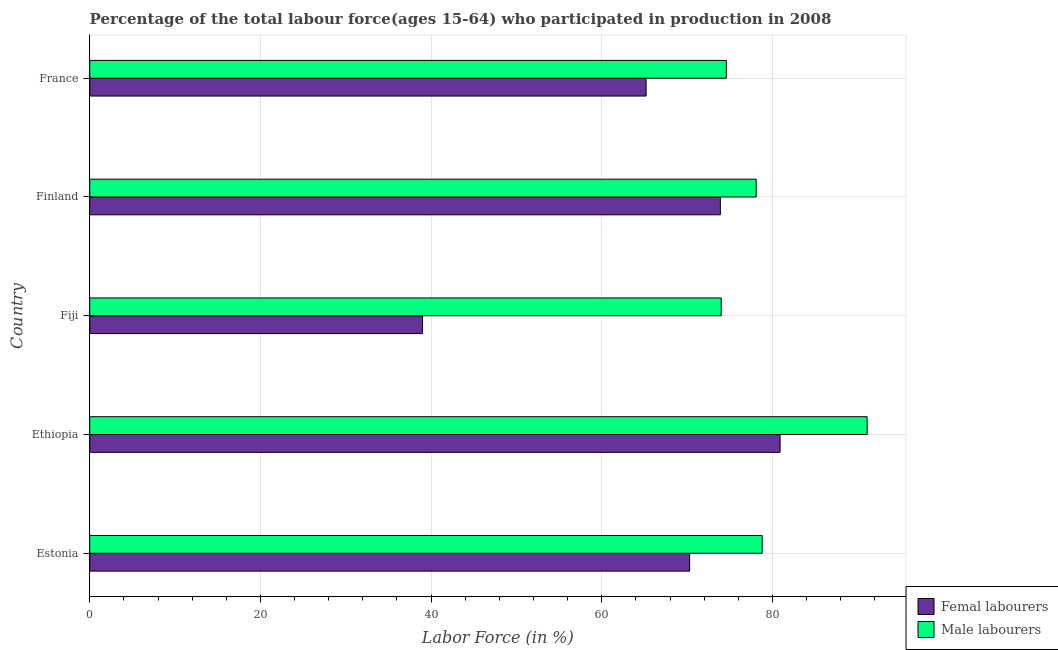How many groups of bars are there?
Your response must be concise. 5. Are the number of bars per tick equal to the number of legend labels?
Ensure brevity in your answer.  Yes. How many bars are there on the 5th tick from the bottom?
Offer a terse response. 2. What is the label of the 5th group of bars from the top?
Provide a short and direct response. Estonia. What is the percentage of male labour force in Estonia?
Provide a short and direct response. 78.8. Across all countries, what is the maximum percentage of female labor force?
Ensure brevity in your answer.  80.9. In which country was the percentage of female labor force maximum?
Your response must be concise. Ethiopia. In which country was the percentage of female labor force minimum?
Offer a very short reply. Fiji. What is the total percentage of female labor force in the graph?
Provide a succinct answer. 329.3. What is the difference between the percentage of female labor force in Estonia and the percentage of male labour force in Ethiopia?
Make the answer very short. -20.8. What is the average percentage of male labour force per country?
Offer a terse response. 79.32. In how many countries, is the percentage of male labour force greater than 88 %?
Offer a very short reply. 1. What is the ratio of the percentage of female labor force in Estonia to that in France?
Offer a terse response. 1.08. Is the sum of the percentage of male labour force in Estonia and Fiji greater than the maximum percentage of female labor force across all countries?
Your answer should be compact. Yes. What does the 1st bar from the top in Estonia represents?
Your answer should be compact. Male labourers. What does the 2nd bar from the bottom in Ethiopia represents?
Your answer should be very brief. Male labourers. Are all the bars in the graph horizontal?
Your response must be concise. Yes. What is the difference between two consecutive major ticks on the X-axis?
Your answer should be very brief. 20. Does the graph contain any zero values?
Keep it short and to the point. No. How are the legend labels stacked?
Keep it short and to the point. Vertical. What is the title of the graph?
Your answer should be compact. Percentage of the total labour force(ages 15-64) who participated in production in 2008. Does "Investment in Transport" appear as one of the legend labels in the graph?
Your answer should be very brief. No. What is the Labor Force (in %) of Femal labourers in Estonia?
Your answer should be very brief. 70.3. What is the Labor Force (in %) of Male labourers in Estonia?
Ensure brevity in your answer.  78.8. What is the Labor Force (in %) of Femal labourers in Ethiopia?
Make the answer very short. 80.9. What is the Labor Force (in %) of Male labourers in Ethiopia?
Your answer should be compact. 91.1. What is the Labor Force (in %) in Male labourers in Fiji?
Provide a short and direct response. 74. What is the Labor Force (in %) of Femal labourers in Finland?
Provide a short and direct response. 73.9. What is the Labor Force (in %) of Male labourers in Finland?
Give a very brief answer. 78.1. What is the Labor Force (in %) in Femal labourers in France?
Your answer should be very brief. 65.2. What is the Labor Force (in %) of Male labourers in France?
Provide a succinct answer. 74.6. Across all countries, what is the maximum Labor Force (in %) of Femal labourers?
Your response must be concise. 80.9. Across all countries, what is the maximum Labor Force (in %) in Male labourers?
Keep it short and to the point. 91.1. Across all countries, what is the minimum Labor Force (in %) in Femal labourers?
Offer a very short reply. 39. Across all countries, what is the minimum Labor Force (in %) of Male labourers?
Offer a terse response. 74. What is the total Labor Force (in %) in Femal labourers in the graph?
Your response must be concise. 329.3. What is the total Labor Force (in %) of Male labourers in the graph?
Ensure brevity in your answer.  396.6. What is the difference between the Labor Force (in %) in Femal labourers in Estonia and that in Ethiopia?
Give a very brief answer. -10.6. What is the difference between the Labor Force (in %) of Male labourers in Estonia and that in Ethiopia?
Make the answer very short. -12.3. What is the difference between the Labor Force (in %) of Femal labourers in Estonia and that in Fiji?
Your answer should be very brief. 31.3. What is the difference between the Labor Force (in %) in Male labourers in Estonia and that in Finland?
Your answer should be compact. 0.7. What is the difference between the Labor Force (in %) of Femal labourers in Ethiopia and that in Fiji?
Your response must be concise. 41.9. What is the difference between the Labor Force (in %) in Femal labourers in Ethiopia and that in Finland?
Offer a very short reply. 7. What is the difference between the Labor Force (in %) in Male labourers in Ethiopia and that in France?
Offer a terse response. 16.5. What is the difference between the Labor Force (in %) in Femal labourers in Fiji and that in Finland?
Ensure brevity in your answer.  -34.9. What is the difference between the Labor Force (in %) in Male labourers in Fiji and that in Finland?
Make the answer very short. -4.1. What is the difference between the Labor Force (in %) in Femal labourers in Fiji and that in France?
Give a very brief answer. -26.2. What is the difference between the Labor Force (in %) in Male labourers in Fiji and that in France?
Make the answer very short. -0.6. What is the difference between the Labor Force (in %) of Femal labourers in Finland and that in France?
Your answer should be compact. 8.7. What is the difference between the Labor Force (in %) of Male labourers in Finland and that in France?
Your response must be concise. 3.5. What is the difference between the Labor Force (in %) in Femal labourers in Estonia and the Labor Force (in %) in Male labourers in Ethiopia?
Give a very brief answer. -20.8. What is the difference between the Labor Force (in %) in Femal labourers in Estonia and the Labor Force (in %) in Male labourers in Fiji?
Your response must be concise. -3.7. What is the difference between the Labor Force (in %) of Femal labourers in Fiji and the Labor Force (in %) of Male labourers in Finland?
Provide a short and direct response. -39.1. What is the difference between the Labor Force (in %) of Femal labourers in Fiji and the Labor Force (in %) of Male labourers in France?
Your answer should be compact. -35.6. What is the difference between the Labor Force (in %) of Femal labourers in Finland and the Labor Force (in %) of Male labourers in France?
Give a very brief answer. -0.7. What is the average Labor Force (in %) of Femal labourers per country?
Ensure brevity in your answer.  65.86. What is the average Labor Force (in %) in Male labourers per country?
Your response must be concise. 79.32. What is the difference between the Labor Force (in %) in Femal labourers and Labor Force (in %) in Male labourers in Ethiopia?
Your answer should be very brief. -10.2. What is the difference between the Labor Force (in %) in Femal labourers and Labor Force (in %) in Male labourers in Fiji?
Keep it short and to the point. -35. What is the difference between the Labor Force (in %) of Femal labourers and Labor Force (in %) of Male labourers in Finland?
Offer a very short reply. -4.2. What is the ratio of the Labor Force (in %) in Femal labourers in Estonia to that in Ethiopia?
Your response must be concise. 0.87. What is the ratio of the Labor Force (in %) of Male labourers in Estonia to that in Ethiopia?
Ensure brevity in your answer.  0.86. What is the ratio of the Labor Force (in %) in Femal labourers in Estonia to that in Fiji?
Provide a short and direct response. 1.8. What is the ratio of the Labor Force (in %) of Male labourers in Estonia to that in Fiji?
Ensure brevity in your answer.  1.06. What is the ratio of the Labor Force (in %) in Femal labourers in Estonia to that in Finland?
Your answer should be very brief. 0.95. What is the ratio of the Labor Force (in %) of Femal labourers in Estonia to that in France?
Provide a succinct answer. 1.08. What is the ratio of the Labor Force (in %) of Male labourers in Estonia to that in France?
Offer a very short reply. 1.06. What is the ratio of the Labor Force (in %) in Femal labourers in Ethiopia to that in Fiji?
Provide a succinct answer. 2.07. What is the ratio of the Labor Force (in %) in Male labourers in Ethiopia to that in Fiji?
Offer a terse response. 1.23. What is the ratio of the Labor Force (in %) in Femal labourers in Ethiopia to that in Finland?
Make the answer very short. 1.09. What is the ratio of the Labor Force (in %) in Male labourers in Ethiopia to that in Finland?
Provide a short and direct response. 1.17. What is the ratio of the Labor Force (in %) of Femal labourers in Ethiopia to that in France?
Make the answer very short. 1.24. What is the ratio of the Labor Force (in %) of Male labourers in Ethiopia to that in France?
Ensure brevity in your answer.  1.22. What is the ratio of the Labor Force (in %) in Femal labourers in Fiji to that in Finland?
Give a very brief answer. 0.53. What is the ratio of the Labor Force (in %) of Male labourers in Fiji to that in Finland?
Make the answer very short. 0.95. What is the ratio of the Labor Force (in %) of Femal labourers in Fiji to that in France?
Ensure brevity in your answer.  0.6. What is the ratio of the Labor Force (in %) of Femal labourers in Finland to that in France?
Your response must be concise. 1.13. What is the ratio of the Labor Force (in %) in Male labourers in Finland to that in France?
Offer a very short reply. 1.05. What is the difference between the highest and the lowest Labor Force (in %) in Femal labourers?
Make the answer very short. 41.9. 